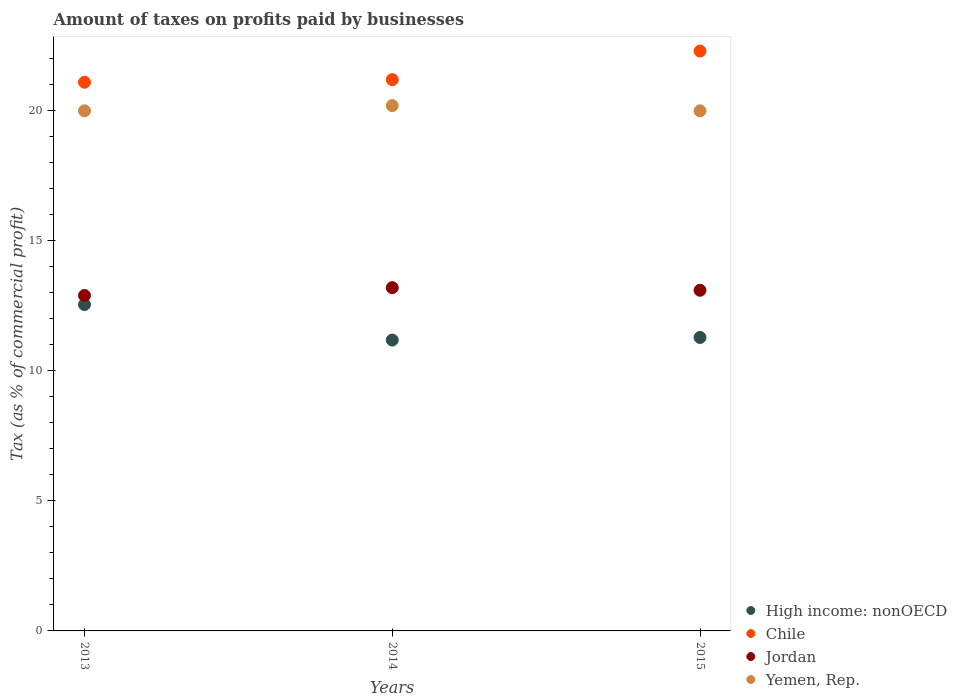How many different coloured dotlines are there?
Your answer should be very brief. 4. Is the number of dotlines equal to the number of legend labels?
Give a very brief answer. Yes. What is the percentage of taxes paid by businesses in Chile in 2013?
Your response must be concise. 21.1. Across all years, what is the maximum percentage of taxes paid by businesses in Chile?
Keep it short and to the point. 22.3. Across all years, what is the minimum percentage of taxes paid by businesses in Chile?
Your answer should be very brief. 21.1. In which year was the percentage of taxes paid by businesses in High income: nonOECD maximum?
Keep it short and to the point. 2013. What is the total percentage of taxes paid by businesses in Chile in the graph?
Your answer should be compact. 64.6. What is the difference between the percentage of taxes paid by businesses in Jordan in 2013 and that in 2014?
Make the answer very short. -0.3. What is the difference between the percentage of taxes paid by businesses in Yemen, Rep. in 2015 and the percentage of taxes paid by businesses in Chile in 2013?
Give a very brief answer. -1.1. What is the average percentage of taxes paid by businesses in Chile per year?
Your response must be concise. 21.53. In the year 2014, what is the difference between the percentage of taxes paid by businesses in High income: nonOECD and percentage of taxes paid by businesses in Jordan?
Offer a very short reply. -2.01. What is the ratio of the percentage of taxes paid by businesses in High income: nonOECD in 2013 to that in 2015?
Your answer should be very brief. 1.11. Is the difference between the percentage of taxes paid by businesses in High income: nonOECD in 2013 and 2014 greater than the difference between the percentage of taxes paid by businesses in Jordan in 2013 and 2014?
Offer a terse response. Yes. What is the difference between the highest and the second highest percentage of taxes paid by businesses in Chile?
Make the answer very short. 1.1. What is the difference between the highest and the lowest percentage of taxes paid by businesses in Jordan?
Offer a very short reply. 0.3. In how many years, is the percentage of taxes paid by businesses in Yemen, Rep. greater than the average percentage of taxes paid by businesses in Yemen, Rep. taken over all years?
Your answer should be very brief. 1. Is the sum of the percentage of taxes paid by businesses in Yemen, Rep. in 2013 and 2015 greater than the maximum percentage of taxes paid by businesses in Chile across all years?
Keep it short and to the point. Yes. Is it the case that in every year, the sum of the percentage of taxes paid by businesses in High income: nonOECD and percentage of taxes paid by businesses in Jordan  is greater than the percentage of taxes paid by businesses in Chile?
Make the answer very short. Yes. What is the difference between two consecutive major ticks on the Y-axis?
Your response must be concise. 5. Are the values on the major ticks of Y-axis written in scientific E-notation?
Offer a terse response. No. Where does the legend appear in the graph?
Provide a succinct answer. Bottom right. What is the title of the graph?
Ensure brevity in your answer.  Amount of taxes on profits paid by businesses. What is the label or title of the X-axis?
Your answer should be very brief. Years. What is the label or title of the Y-axis?
Provide a short and direct response. Tax (as % of commercial profit). What is the Tax (as % of commercial profit) in High income: nonOECD in 2013?
Your answer should be compact. 12.55. What is the Tax (as % of commercial profit) in Chile in 2013?
Keep it short and to the point. 21.1. What is the Tax (as % of commercial profit) in Jordan in 2013?
Make the answer very short. 12.9. What is the Tax (as % of commercial profit) in Yemen, Rep. in 2013?
Your answer should be very brief. 20. What is the Tax (as % of commercial profit) of High income: nonOECD in 2014?
Your answer should be compact. 11.19. What is the Tax (as % of commercial profit) in Chile in 2014?
Your answer should be compact. 21.2. What is the Tax (as % of commercial profit) in Yemen, Rep. in 2014?
Make the answer very short. 20.2. What is the Tax (as % of commercial profit) of High income: nonOECD in 2015?
Keep it short and to the point. 11.29. What is the Tax (as % of commercial profit) of Chile in 2015?
Ensure brevity in your answer.  22.3. Across all years, what is the maximum Tax (as % of commercial profit) of High income: nonOECD?
Provide a short and direct response. 12.55. Across all years, what is the maximum Tax (as % of commercial profit) of Chile?
Make the answer very short. 22.3. Across all years, what is the maximum Tax (as % of commercial profit) in Jordan?
Your response must be concise. 13.2. Across all years, what is the maximum Tax (as % of commercial profit) in Yemen, Rep.?
Your answer should be compact. 20.2. Across all years, what is the minimum Tax (as % of commercial profit) in High income: nonOECD?
Your answer should be very brief. 11.19. Across all years, what is the minimum Tax (as % of commercial profit) in Chile?
Offer a terse response. 21.1. Across all years, what is the minimum Tax (as % of commercial profit) in Yemen, Rep.?
Keep it short and to the point. 20. What is the total Tax (as % of commercial profit) in High income: nonOECD in the graph?
Provide a succinct answer. 35.02. What is the total Tax (as % of commercial profit) in Chile in the graph?
Provide a short and direct response. 64.6. What is the total Tax (as % of commercial profit) of Jordan in the graph?
Keep it short and to the point. 39.2. What is the total Tax (as % of commercial profit) of Yemen, Rep. in the graph?
Your response must be concise. 60.2. What is the difference between the Tax (as % of commercial profit) of High income: nonOECD in 2013 and that in 2014?
Provide a succinct answer. 1.36. What is the difference between the Tax (as % of commercial profit) of High income: nonOECD in 2013 and that in 2015?
Make the answer very short. 1.26. What is the difference between the Tax (as % of commercial profit) in Chile in 2014 and that in 2015?
Your answer should be very brief. -1.1. What is the difference between the Tax (as % of commercial profit) in Yemen, Rep. in 2014 and that in 2015?
Provide a succinct answer. 0.2. What is the difference between the Tax (as % of commercial profit) in High income: nonOECD in 2013 and the Tax (as % of commercial profit) in Chile in 2014?
Provide a short and direct response. -8.65. What is the difference between the Tax (as % of commercial profit) in High income: nonOECD in 2013 and the Tax (as % of commercial profit) in Jordan in 2014?
Offer a terse response. -0.65. What is the difference between the Tax (as % of commercial profit) of High income: nonOECD in 2013 and the Tax (as % of commercial profit) of Yemen, Rep. in 2014?
Make the answer very short. -7.65. What is the difference between the Tax (as % of commercial profit) of Chile in 2013 and the Tax (as % of commercial profit) of Yemen, Rep. in 2014?
Keep it short and to the point. 0.9. What is the difference between the Tax (as % of commercial profit) of High income: nonOECD in 2013 and the Tax (as % of commercial profit) of Chile in 2015?
Offer a terse response. -9.75. What is the difference between the Tax (as % of commercial profit) in High income: nonOECD in 2013 and the Tax (as % of commercial profit) in Jordan in 2015?
Give a very brief answer. -0.55. What is the difference between the Tax (as % of commercial profit) in High income: nonOECD in 2013 and the Tax (as % of commercial profit) in Yemen, Rep. in 2015?
Your answer should be very brief. -7.45. What is the difference between the Tax (as % of commercial profit) of Chile in 2013 and the Tax (as % of commercial profit) of Jordan in 2015?
Provide a succinct answer. 8. What is the difference between the Tax (as % of commercial profit) in Jordan in 2013 and the Tax (as % of commercial profit) in Yemen, Rep. in 2015?
Provide a succinct answer. -7.1. What is the difference between the Tax (as % of commercial profit) in High income: nonOECD in 2014 and the Tax (as % of commercial profit) in Chile in 2015?
Offer a very short reply. -11.11. What is the difference between the Tax (as % of commercial profit) in High income: nonOECD in 2014 and the Tax (as % of commercial profit) in Jordan in 2015?
Your answer should be very brief. -1.91. What is the difference between the Tax (as % of commercial profit) of High income: nonOECD in 2014 and the Tax (as % of commercial profit) of Yemen, Rep. in 2015?
Make the answer very short. -8.81. What is the difference between the Tax (as % of commercial profit) of Chile in 2014 and the Tax (as % of commercial profit) of Yemen, Rep. in 2015?
Offer a very short reply. 1.2. What is the difference between the Tax (as % of commercial profit) of Jordan in 2014 and the Tax (as % of commercial profit) of Yemen, Rep. in 2015?
Your answer should be very brief. -6.8. What is the average Tax (as % of commercial profit) in High income: nonOECD per year?
Your response must be concise. 11.67. What is the average Tax (as % of commercial profit) in Chile per year?
Provide a succinct answer. 21.53. What is the average Tax (as % of commercial profit) in Jordan per year?
Ensure brevity in your answer.  13.07. What is the average Tax (as % of commercial profit) in Yemen, Rep. per year?
Provide a short and direct response. 20.07. In the year 2013, what is the difference between the Tax (as % of commercial profit) in High income: nonOECD and Tax (as % of commercial profit) in Chile?
Provide a short and direct response. -8.55. In the year 2013, what is the difference between the Tax (as % of commercial profit) of High income: nonOECD and Tax (as % of commercial profit) of Jordan?
Keep it short and to the point. -0.35. In the year 2013, what is the difference between the Tax (as % of commercial profit) of High income: nonOECD and Tax (as % of commercial profit) of Yemen, Rep.?
Your answer should be very brief. -7.45. In the year 2014, what is the difference between the Tax (as % of commercial profit) of High income: nonOECD and Tax (as % of commercial profit) of Chile?
Make the answer very short. -10.01. In the year 2014, what is the difference between the Tax (as % of commercial profit) of High income: nonOECD and Tax (as % of commercial profit) of Jordan?
Your response must be concise. -2.01. In the year 2014, what is the difference between the Tax (as % of commercial profit) of High income: nonOECD and Tax (as % of commercial profit) of Yemen, Rep.?
Make the answer very short. -9.01. In the year 2014, what is the difference between the Tax (as % of commercial profit) of Chile and Tax (as % of commercial profit) of Jordan?
Ensure brevity in your answer.  8. In the year 2014, what is the difference between the Tax (as % of commercial profit) of Jordan and Tax (as % of commercial profit) of Yemen, Rep.?
Provide a short and direct response. -7. In the year 2015, what is the difference between the Tax (as % of commercial profit) in High income: nonOECD and Tax (as % of commercial profit) in Chile?
Ensure brevity in your answer.  -11.01. In the year 2015, what is the difference between the Tax (as % of commercial profit) in High income: nonOECD and Tax (as % of commercial profit) in Jordan?
Your answer should be very brief. -1.81. In the year 2015, what is the difference between the Tax (as % of commercial profit) of High income: nonOECD and Tax (as % of commercial profit) of Yemen, Rep.?
Provide a succinct answer. -8.71. In the year 2015, what is the difference between the Tax (as % of commercial profit) of Chile and Tax (as % of commercial profit) of Jordan?
Offer a very short reply. 9.2. In the year 2015, what is the difference between the Tax (as % of commercial profit) in Chile and Tax (as % of commercial profit) in Yemen, Rep.?
Provide a short and direct response. 2.3. In the year 2015, what is the difference between the Tax (as % of commercial profit) of Jordan and Tax (as % of commercial profit) of Yemen, Rep.?
Make the answer very short. -6.9. What is the ratio of the Tax (as % of commercial profit) of High income: nonOECD in 2013 to that in 2014?
Offer a very short reply. 1.12. What is the ratio of the Tax (as % of commercial profit) of Chile in 2013 to that in 2014?
Make the answer very short. 1. What is the ratio of the Tax (as % of commercial profit) of Jordan in 2013 to that in 2014?
Offer a very short reply. 0.98. What is the ratio of the Tax (as % of commercial profit) in High income: nonOECD in 2013 to that in 2015?
Offer a terse response. 1.11. What is the ratio of the Tax (as % of commercial profit) of Chile in 2013 to that in 2015?
Your response must be concise. 0.95. What is the ratio of the Tax (as % of commercial profit) of Jordan in 2013 to that in 2015?
Your response must be concise. 0.98. What is the ratio of the Tax (as % of commercial profit) in Yemen, Rep. in 2013 to that in 2015?
Provide a succinct answer. 1. What is the ratio of the Tax (as % of commercial profit) of Chile in 2014 to that in 2015?
Offer a terse response. 0.95. What is the ratio of the Tax (as % of commercial profit) of Jordan in 2014 to that in 2015?
Provide a short and direct response. 1.01. What is the difference between the highest and the second highest Tax (as % of commercial profit) in High income: nonOECD?
Give a very brief answer. 1.26. What is the difference between the highest and the second highest Tax (as % of commercial profit) of Yemen, Rep.?
Provide a short and direct response. 0.2. What is the difference between the highest and the lowest Tax (as % of commercial profit) in High income: nonOECD?
Offer a terse response. 1.36. What is the difference between the highest and the lowest Tax (as % of commercial profit) of Chile?
Make the answer very short. 1.2. What is the difference between the highest and the lowest Tax (as % of commercial profit) in Jordan?
Your answer should be compact. 0.3. 